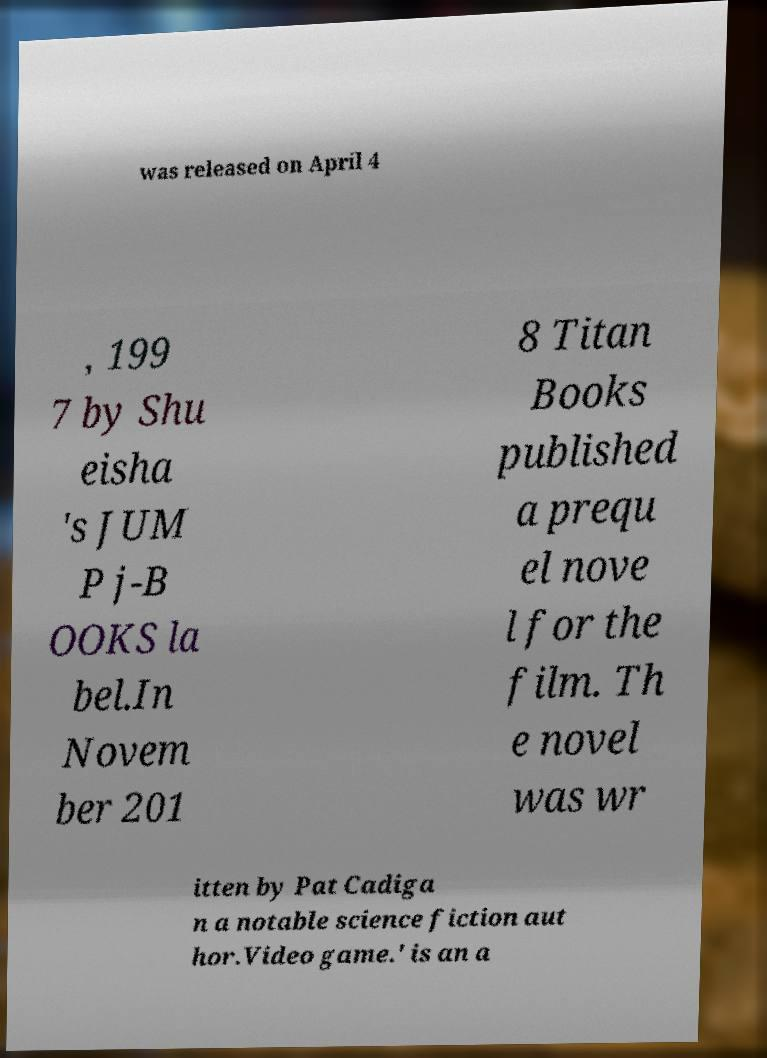For documentation purposes, I need the text within this image transcribed. Could you provide that? was released on April 4 , 199 7 by Shu eisha 's JUM P j-B OOKS la bel.In Novem ber 201 8 Titan Books published a prequ el nove l for the film. Th e novel was wr itten by Pat Cadiga n a notable science fiction aut hor.Video game.' is an a 